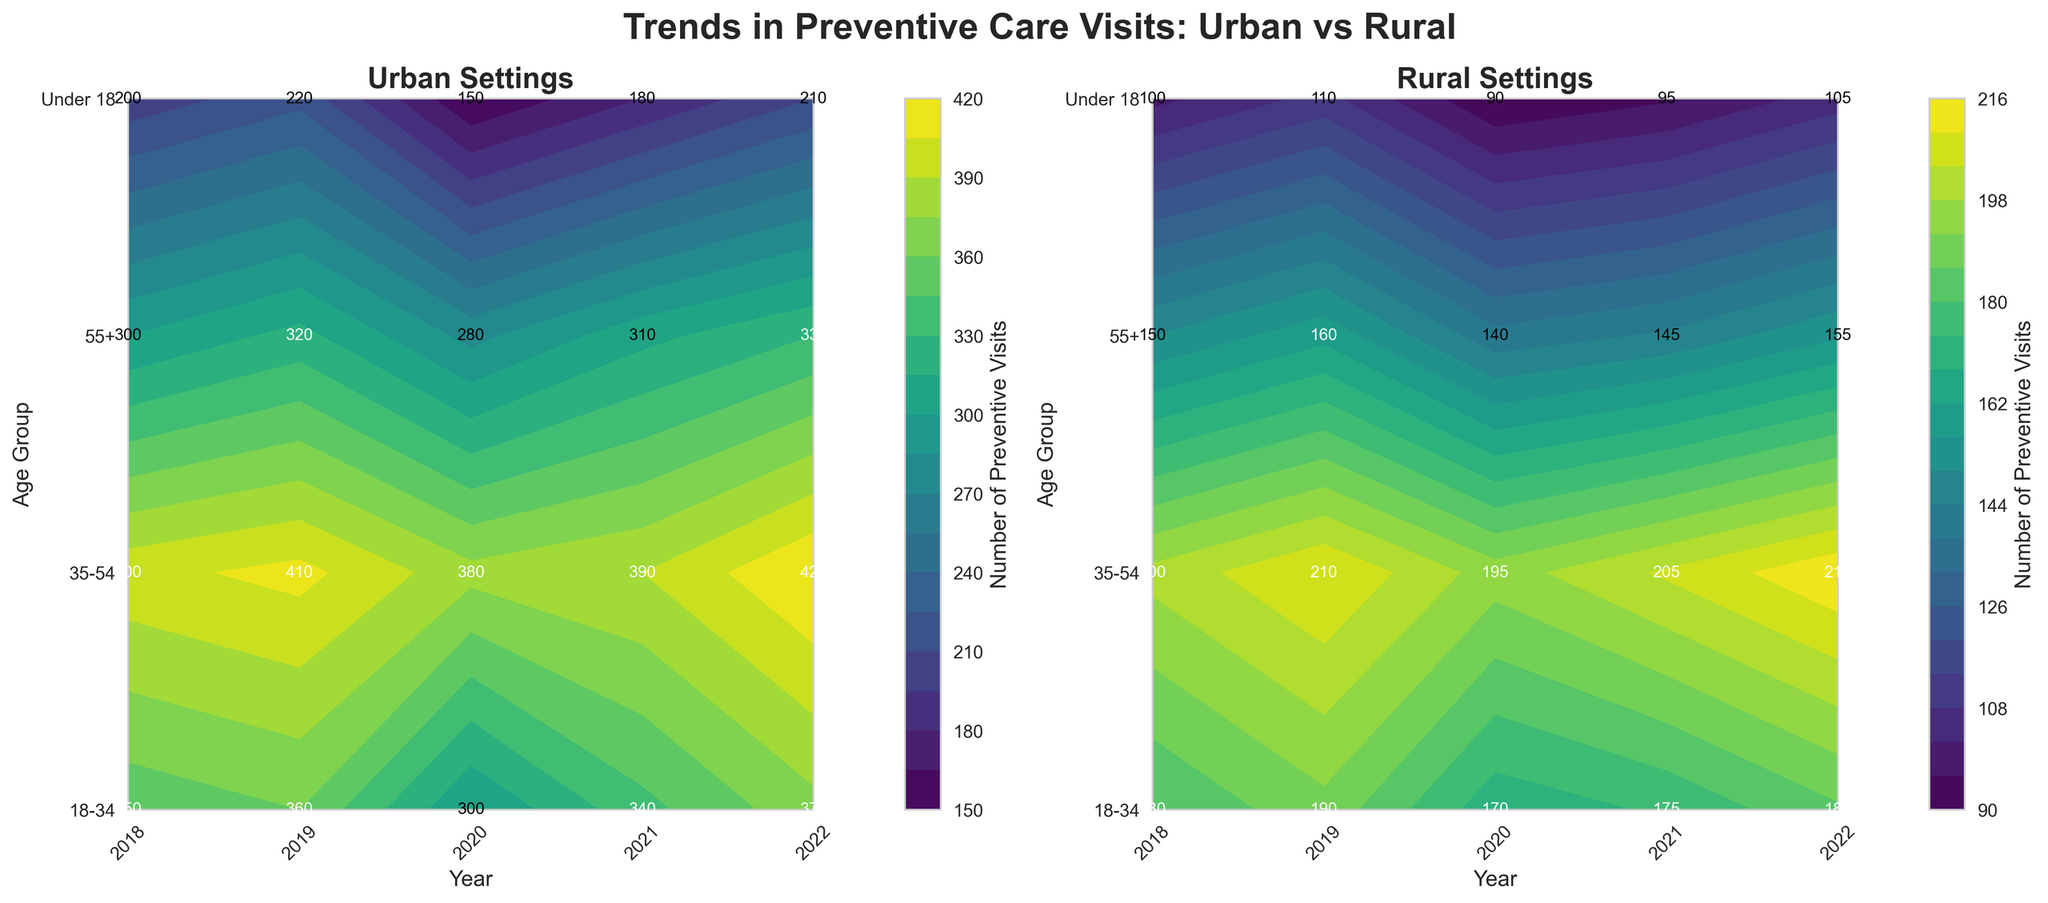What is the title of the figure? The title is usually placed at the top center of the plot. In this case, it reads: "Trends in Preventive Care Visits: Urban vs Rural"
Answer: Trends in Preventive Care Visits: Urban vs Rural What is the time range covered in the figure? By looking at the x-axis labels, the years displayed range from 2018 to 2022.
Answer: 2018 to 2022 Which age group in rural settings had the highest number of preventive visits in 2022? Find the column for 2022 in the rural subplot and identify the age group with the highest number of visits. It shows the age group "35-54".
Answer: 35-54 How do the preventive visits for 'Under 18' in urban settings in 2020 compare to 2021? Check the contour values for 'Under 18' in the urban subplot for 2020 and 2021. In 2020, it is 150, and in 2021, it is 180. Comparing these values, 2021 has more visits than 2020.
Answer: 2021 is higher What is the approximate range of preventive visits for the age group '18-34' in urban settings over the years? Check the contour values for '18-34' in the urban subplot across all years. The values range from a low of 300 in 2020 to a high of 370 in 2022.
Answer: 300 to 370 Which setting, urban or rural, had a more significant decrease in preventive visits for '55+' from 2019 to 2020? Compare the number of visits for '55+' in both settings between 2019 and 2020. In the urban setting, it drops from 320 to 280 (a decrease of 40), while in the rural setting, it drops from 160 to 140 (a decrease of 20). The urban setting had a more significant decrease.
Answer: Urban had a more significant decrease What trend can be observed for the age group '35-54' in rural settings from 2018 to 2022? Follow the contour values for '35-54' in rural settings from 2018 to 2022. The values are 200 in 2018, 210 in 2019, 195 in 2020, 205 in 2021, and 215 in 2022. There is a general increasing trend with a slight dip in 2020.
Answer: Increasing trend with a slight dip in 2020 By how much did preventive visits for 'Under 18' in urban settings increase from 2020 to 2022? Check the contour values for 'Under 18' in urban settings for 2020 and 2022. The values are 150 in 2020 and 210 in 2022. The increase is 210 - 150 = 60 visits.
Answer: 60 visits Are there any age groups in rural settings that experienced a decline in preventive visits from 2018 to 2022? If so, which ones? Check the contour values for each age group in rural settings from 2018 to 2022. None of the age groups show an overall decline when comparing 2018 to 2022.
Answer: No age groups experienced a decline Which urban age group had the least variation in preventive visits over the years? Calculate the range (difference between maximum and minimum values) for each age group in urban settings. '55+' has values ranging from 280 to 330, '18-34' from 300 to 370, '35-54' from 380 to 420, and 'Under 18' from 150 to 220. The '55+' group has the least variation (50).
Answer: 55+ 